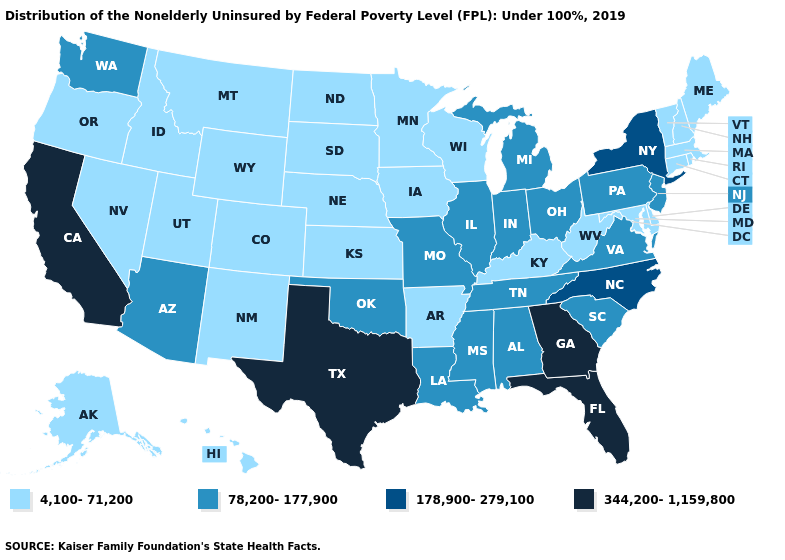Does the first symbol in the legend represent the smallest category?
Be succinct. Yes. What is the value of Kentucky?
Give a very brief answer. 4,100-71,200. Among the states that border Montana , which have the lowest value?
Write a very short answer. Idaho, North Dakota, South Dakota, Wyoming. Name the states that have a value in the range 78,200-177,900?
Quick response, please. Alabama, Arizona, Illinois, Indiana, Louisiana, Michigan, Mississippi, Missouri, New Jersey, Ohio, Oklahoma, Pennsylvania, South Carolina, Tennessee, Virginia, Washington. What is the lowest value in states that border Montana?
Keep it brief. 4,100-71,200. Which states have the lowest value in the South?
Keep it brief. Arkansas, Delaware, Kentucky, Maryland, West Virginia. Among the states that border Alabama , does Georgia have the highest value?
Answer briefly. Yes. What is the value of Oklahoma?
Write a very short answer. 78,200-177,900. What is the highest value in the USA?
Answer briefly. 344,200-1,159,800. Does New Jersey have the highest value in the USA?
Give a very brief answer. No. Name the states that have a value in the range 4,100-71,200?
Write a very short answer. Alaska, Arkansas, Colorado, Connecticut, Delaware, Hawaii, Idaho, Iowa, Kansas, Kentucky, Maine, Maryland, Massachusetts, Minnesota, Montana, Nebraska, Nevada, New Hampshire, New Mexico, North Dakota, Oregon, Rhode Island, South Dakota, Utah, Vermont, West Virginia, Wisconsin, Wyoming. Does the first symbol in the legend represent the smallest category?
Give a very brief answer. Yes. What is the value of Pennsylvania?
Quick response, please. 78,200-177,900. Name the states that have a value in the range 78,200-177,900?
Quick response, please. Alabama, Arizona, Illinois, Indiana, Louisiana, Michigan, Mississippi, Missouri, New Jersey, Ohio, Oklahoma, Pennsylvania, South Carolina, Tennessee, Virginia, Washington. Does Maine have a lower value than Colorado?
Quick response, please. No. 